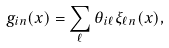Convert formula to latex. <formula><loc_0><loc_0><loc_500><loc_500>g _ { i n } ( x ) = \sum _ { \ell } \theta _ { i \ell } \xi _ { \ell n } ( x ) ,</formula> 